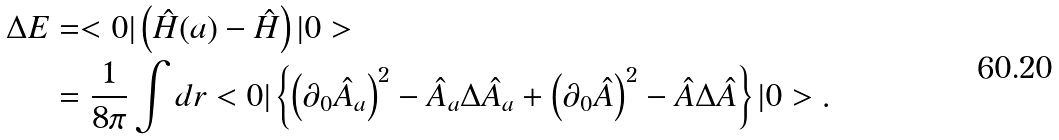Convert formula to latex. <formula><loc_0><loc_0><loc_500><loc_500>\Delta E & = < 0 | \left ( \hat { H } ( a ) - \hat { H } \right ) | 0 > \\ & = \frac { 1 } { 8 \pi } \int d r < 0 | \left \{ \left ( \partial _ { 0 } \hat { A } _ { a } \right ) ^ { 2 } - \hat { A } _ { a } \Delta \hat { A } _ { a } + \left ( \partial _ { 0 } \hat { A } \right ) ^ { 2 } - \hat { A } \Delta \hat { A } \right \} | 0 > .</formula> 